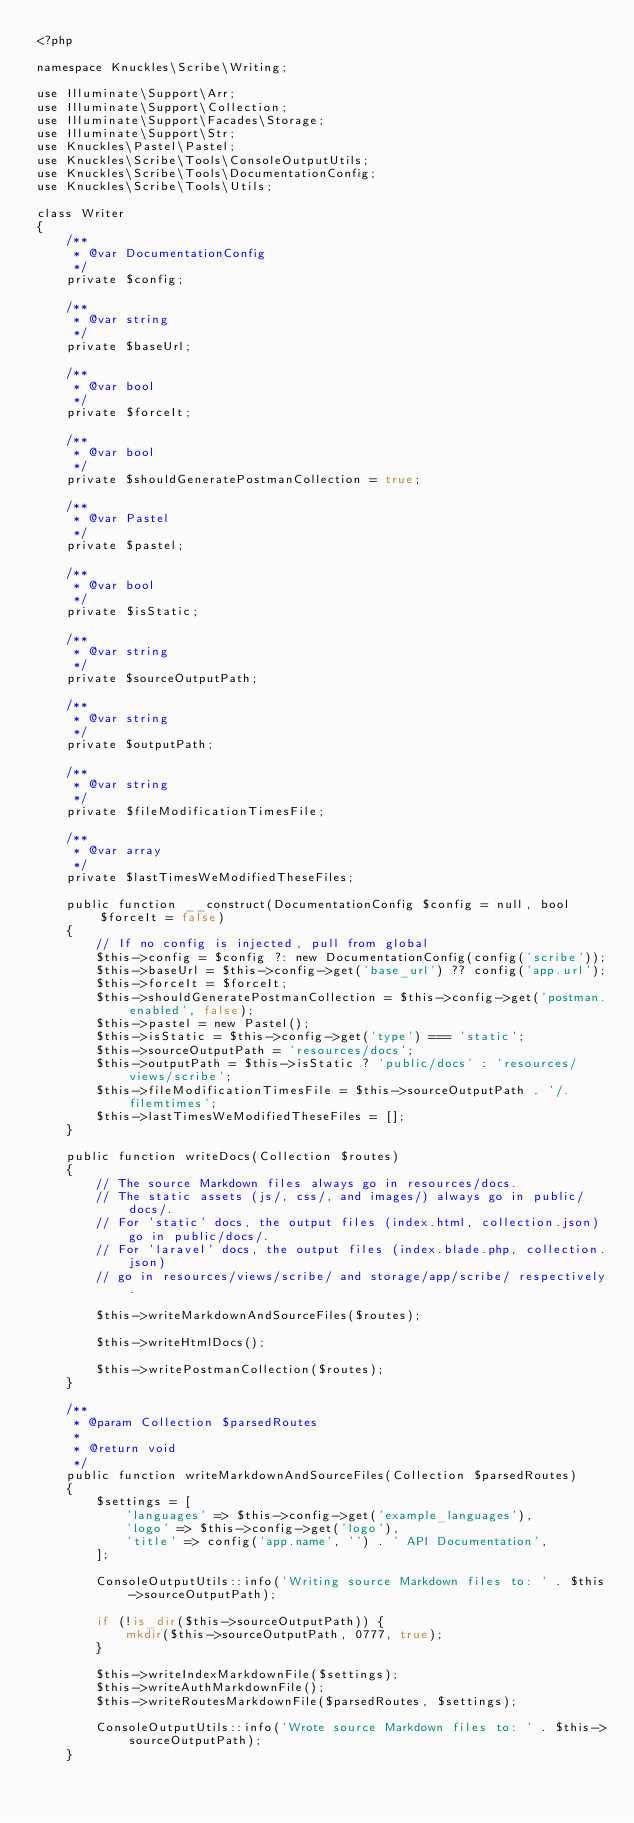<code> <loc_0><loc_0><loc_500><loc_500><_PHP_><?php

namespace Knuckles\Scribe\Writing;

use Illuminate\Support\Arr;
use Illuminate\Support\Collection;
use Illuminate\Support\Facades\Storage;
use Illuminate\Support\Str;
use Knuckles\Pastel\Pastel;
use Knuckles\Scribe\Tools\ConsoleOutputUtils;
use Knuckles\Scribe\Tools\DocumentationConfig;
use Knuckles\Scribe\Tools\Utils;

class Writer
{
    /**
     * @var DocumentationConfig
     */
    private $config;

    /**
     * @var string
     */
    private $baseUrl;

    /**
     * @var bool
     */
    private $forceIt;

    /**
     * @var bool
     */
    private $shouldGeneratePostmanCollection = true;

    /**
     * @var Pastel
     */
    private $pastel;

    /**
     * @var bool
     */
    private $isStatic;

    /**
     * @var string
     */
    private $sourceOutputPath;

    /**
     * @var string
     */
    private $outputPath;

    /**
     * @var string
     */
    private $fileModificationTimesFile;

    /**
     * @var array
     */
    private $lastTimesWeModifiedTheseFiles;

    public function __construct(DocumentationConfig $config = null, bool $forceIt = false)
    {
        // If no config is injected, pull from global
        $this->config = $config ?: new DocumentationConfig(config('scribe'));
        $this->baseUrl = $this->config->get('base_url') ?? config('app.url');
        $this->forceIt = $forceIt;
        $this->shouldGeneratePostmanCollection = $this->config->get('postman.enabled', false);
        $this->pastel = new Pastel();
        $this->isStatic = $this->config->get('type') === 'static';
        $this->sourceOutputPath = 'resources/docs';
        $this->outputPath = $this->isStatic ? 'public/docs' : 'resources/views/scribe';
        $this->fileModificationTimesFile = $this->sourceOutputPath . '/.filemtimes';
        $this->lastTimesWeModifiedTheseFiles = [];
    }

    public function writeDocs(Collection $routes)
    {
        // The source Markdown files always go in resources/docs.
        // The static assets (js/, css/, and images/) always go in public/docs/.
        // For 'static' docs, the output files (index.html, collection.json) go in public/docs/.
        // For 'laravel' docs, the output files (index.blade.php, collection.json)
        // go in resources/views/scribe/ and storage/app/scribe/ respectively.

        $this->writeMarkdownAndSourceFiles($routes);

        $this->writeHtmlDocs();

        $this->writePostmanCollection($routes);
    }

    /**
     * @param Collection $parsedRoutes
     *
     * @return void
     */
    public function writeMarkdownAndSourceFiles(Collection $parsedRoutes)
    {
        $settings = [
            'languages' => $this->config->get('example_languages'),
            'logo' => $this->config->get('logo'),
            'title' => config('app.name', '') . ' API Documentation',
        ];

        ConsoleOutputUtils::info('Writing source Markdown files to: ' . $this->sourceOutputPath);

        if (!is_dir($this->sourceOutputPath)) {
            mkdir($this->sourceOutputPath, 0777, true);
        }

        $this->writeIndexMarkdownFile($settings);
        $this->writeAuthMarkdownFile();
        $this->writeRoutesMarkdownFile($parsedRoutes, $settings);

        ConsoleOutputUtils::info('Wrote source Markdown files to: ' . $this->sourceOutputPath);
    }
</code> 